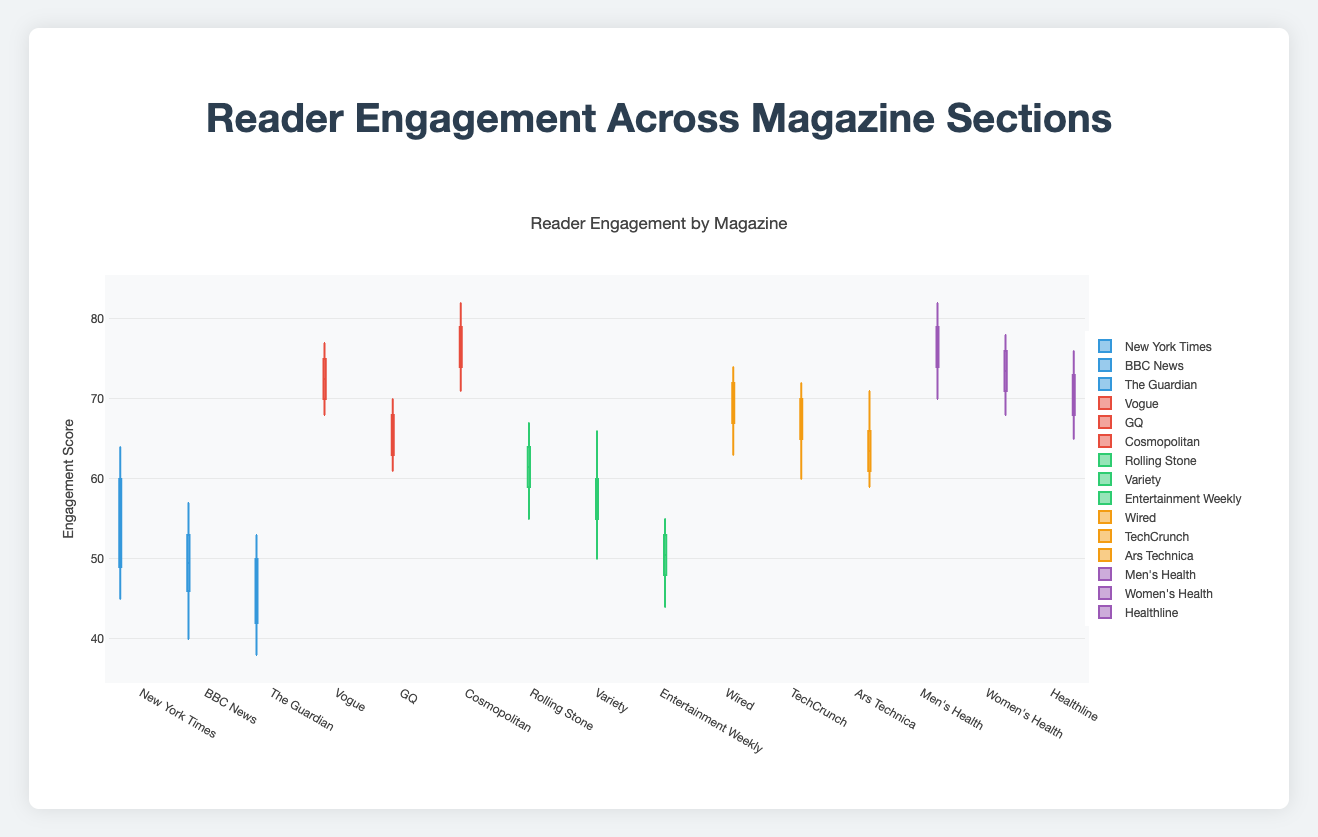What's the median engagement score for Wired in the Technology section? To find the median, we need to arrange the engagement scores in ascending order and then determine the middle value. Wired has scores of [68, 72, 65, 70, 69, 67, 71, 74, 63, 73]. In ascending order: [63, 65, 67, 68, 69, 70, 71, 72, 73, 74]. The median is the average of the 5th and 6th values: (69 + 70) / 2 = 69.5.
Answer: 69.5 What section has the largest range of engagement scores? The range is calculated as the difference between the maximum and minimum values in each section. For each section:
- News: [64-38] = 26
- Lifestyle: [82-61] = 21
- Entertainment: [67-44] = 23
- Technology: [74-59] = 15
- Health: [82-65] = 17
The largest range is for the News section with a range of 26.
Answer: News Which magazine in the Health section has the highest median engagement score? For the Health section, we will calculate the median for each magazine. 
- Men's Health: Scores = [77, 80, 72, 78, 76, 75, 79, 82, 70, 74]. Median = (75 + 76) / 2 = 75.5.
- Women's Health: Scores = [74, 77, 71, 75, 72, 76, 70, 78, 68, 73]. Median = (73 + 74) / 2 = 73.5.
- Healthline: Scores = [70, 73, 68, 71, 69, 74, 67, 76, 65, 72]. Median = (69 + 70) / 2 = 69.5.
Men's Health has the highest median engagement score of 75.5.
Answer: Men's Health For the Entertainment section, which magazine has the lowest maximum engagement score? We look at the maximum engagement scores for each magazine in the Entertainment section:
- Rolling Stone: 67
- Variety: 66
- Entertainment Weekly: 55
Entertainment Weekly has the lowest maximum engagement score of 55.
Answer: Entertainment Weekly What is the interquartile range (IQR) of engagement scores for Vogue in the Lifestyle section? The IQR is the range between the first quartile (Q1) and the third quartile (Q3). Vogue scores: [72, 75, 70, 74, 68, 77, 71, 73, 69, 76]
- Sorted: [68, 69, 70, 71, 72, 73, 74, 75, 76, 77]
- Q1 (first quartile) is the median of the lower half: (70 + 71) / 2 = 70.5
- Q3 (third quartile) is the median of the upper half: (74 + 75) / 2 = 74.5
- IQR = Q3 - Q1 = 74.5 - 70.5 = 4
The IQR for Vogue is 4.
Answer: 4 Which section shows the smallest variation in engagement scores? Variation can be assessed using the range. We previously found the ranges for each section:
- News: 26
- Lifestyle: 21
- Entertainment: 23
- Technology: 15
- Health: 17
The smallest variation is in the Technology section with a range of 15.
Answer: Technology What is the median engagement score across all sections for Variety? Variety's engagement scores: [55, 58, 53, 60, 56, 57, 61, 66, 50, 59]
- Sorted: [50, 53, 55, 56, 57, 58, 59, 60, 61, 66]
- Median: (57 + 58) / 2 = 57.5
The median engagement score for Variety is 57.5.
Answer: 57.5 